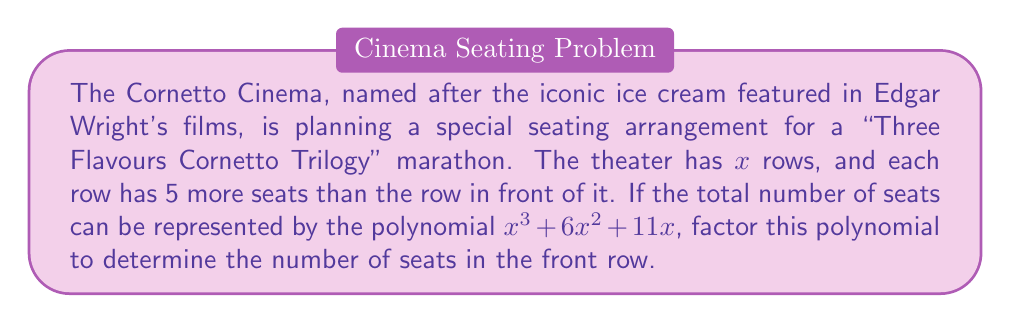What is the answer to this math problem? Let's approach this step-by-step:

1) We're given the polynomial $x^3 + 6x^2 + 11x$, which represents the total number of seats.

2) This polynomial can be factored by taking out the greatest common factor (GCF). We can see that $x$ is common to all terms:

   $x^3 + 6x^2 + 11x = x(x^2 + 6x + 11)$

3) Now we need to factor the quadratic expression inside the parentheses: $x^2 + 6x + 11$

4) To factor this, we need to find two numbers that multiply to give 11 and add up to 6. These numbers are 5 and 1.

5) We can rewrite the quadratic as:

   $x^2 + 5x + x + 11 = x(x + 5) + 1(x + 11)$

6) Factoring out $(x + 11)$, we get:

   $x(x + 5) + 1(x + 11) = (x + 1)(x + 11)$

7) Therefore, our fully factored polynomial is:

   $x(x + 1)(x + 11)$

8) In the context of the problem, $x$ represents the number of rows, and $(x + 11)$ represents the number of seats in the last row.

9) The number of seats in the front row would be 11 less than the last row, which is represented by $(x + 1)$.
Answer: The factored polynomial is $x(x + 1)(x + 11)$, and the number of seats in the front row is represented by $(x + 1)$. 